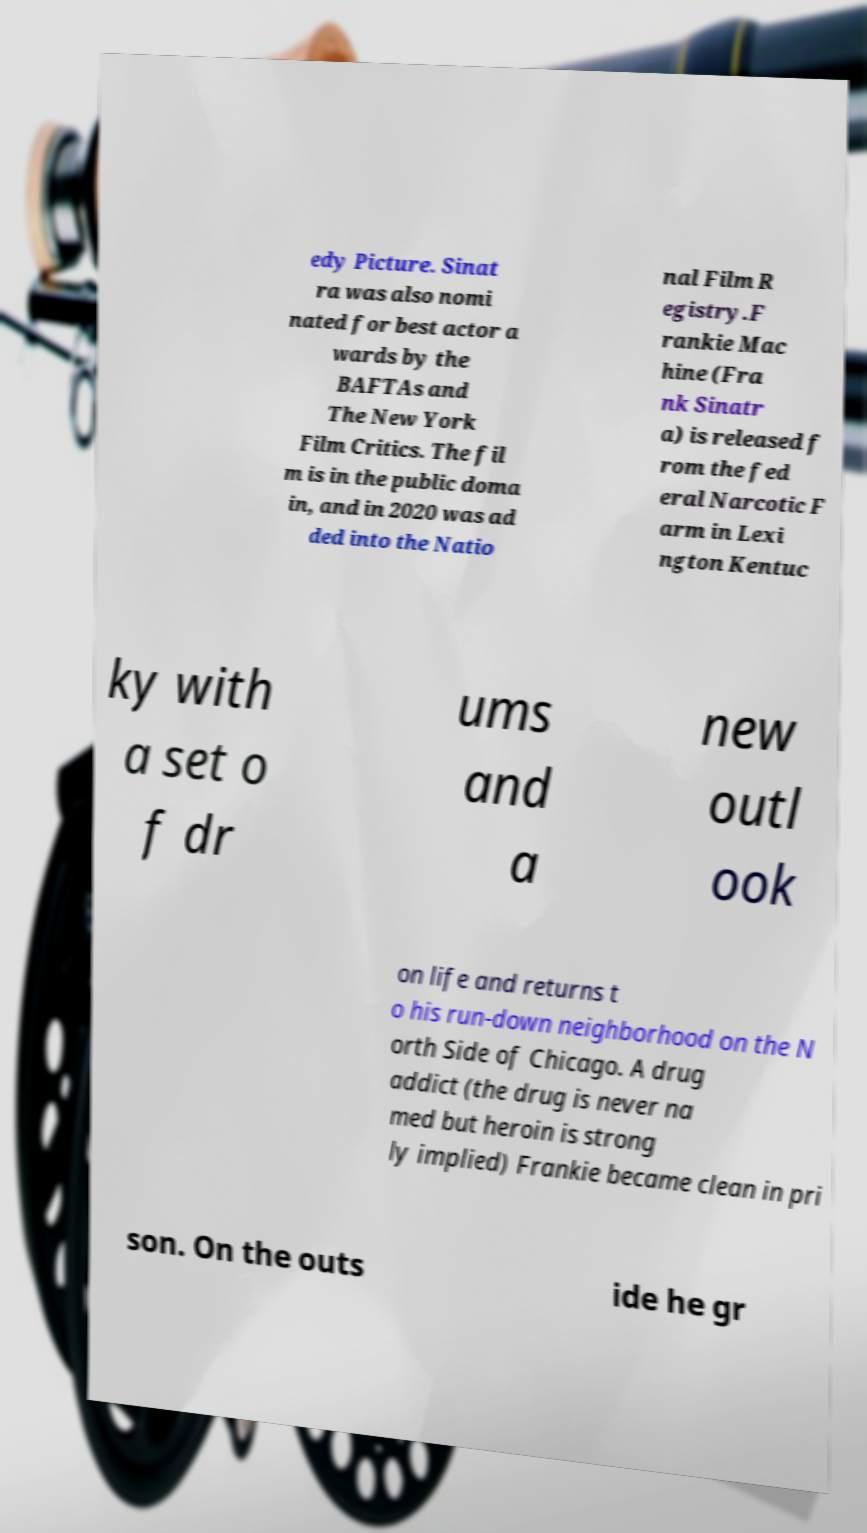Can you read and provide the text displayed in the image?This photo seems to have some interesting text. Can you extract and type it out for me? edy Picture. Sinat ra was also nomi nated for best actor a wards by the BAFTAs and The New York Film Critics. The fil m is in the public doma in, and in 2020 was ad ded into the Natio nal Film R egistry.F rankie Mac hine (Fra nk Sinatr a) is released f rom the fed eral Narcotic F arm in Lexi ngton Kentuc ky with a set o f dr ums and a new outl ook on life and returns t o his run-down neighborhood on the N orth Side of Chicago. A drug addict (the drug is never na med but heroin is strong ly implied) Frankie became clean in pri son. On the outs ide he gr 